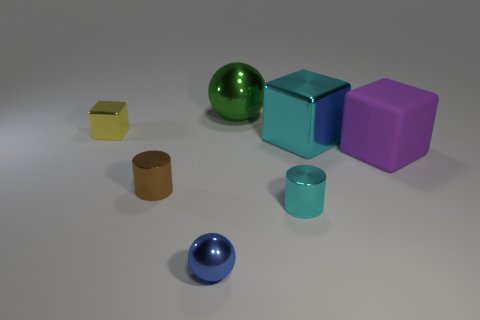Subtract all small cubes. How many cubes are left? 2 Add 2 tiny metal things. How many objects exist? 9 Subtract all cylinders. How many objects are left? 5 Subtract all red cubes. Subtract all gray cylinders. How many cubes are left? 3 Add 2 small metallic things. How many small metallic things exist? 6 Subtract 0 cyan spheres. How many objects are left? 7 Subtract all tiny cyan metal cylinders. Subtract all cubes. How many objects are left? 3 Add 5 purple matte things. How many purple matte things are left? 6 